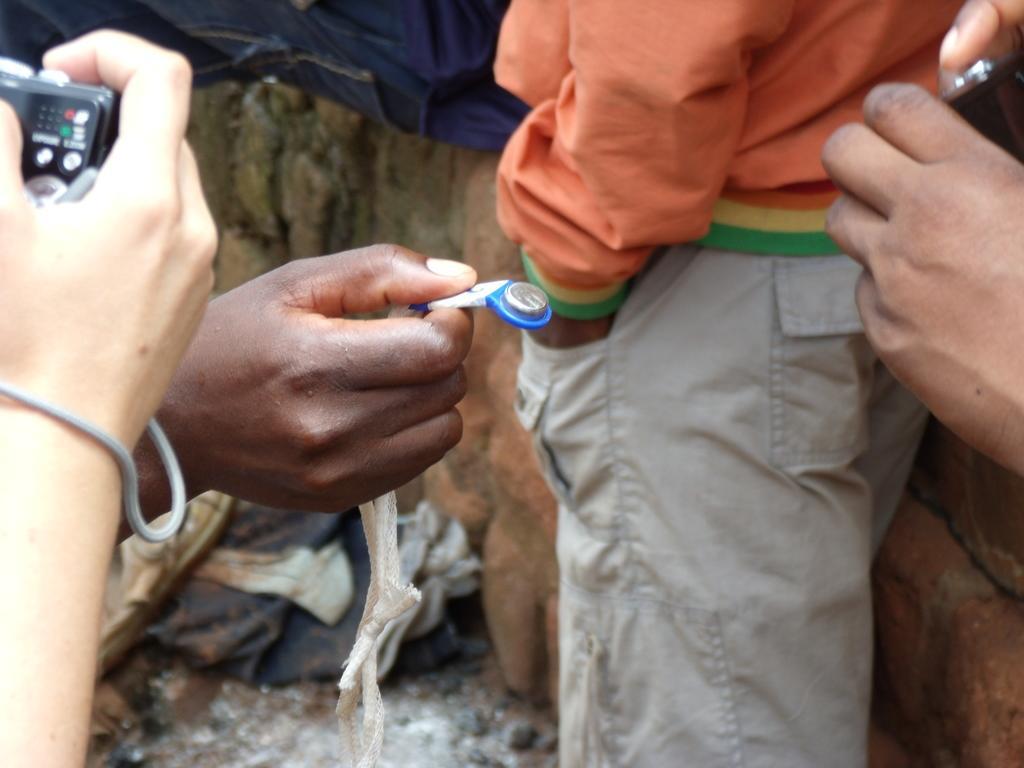In one or two sentences, can you explain what this image depicts? In this image, on the right and on the left, there are persons hands holding cameras and in the center of the image, there is an another person's hand holding an object. In the background, we can see a person standing. 